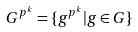<formula> <loc_0><loc_0><loc_500><loc_500>G ^ { p ^ { k } } = \{ g ^ { p ^ { k } } | g \in G \}</formula> 